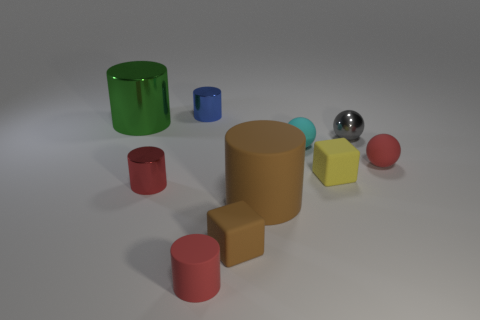What is the shape of the tiny shiny thing that is the same color as the small rubber cylinder?
Offer a very short reply. Cylinder. What is the size of the metal cylinder that is the same color as the small matte cylinder?
Give a very brief answer. Small. There is a tiny metallic thing that is both on the left side of the big brown rubber object and in front of the tiny blue shiny cylinder; what shape is it?
Keep it short and to the point. Cylinder. Is there a tiny metallic ball that has the same color as the tiny rubber cylinder?
Give a very brief answer. No. Are any large gray rubber balls visible?
Give a very brief answer. No. There is a tiny matte sphere that is behind the tiny red ball; what color is it?
Ensure brevity in your answer.  Cyan. Do the red shiny cylinder and the red rubber thing that is on the right side of the brown rubber block have the same size?
Provide a short and direct response. Yes. There is a metal object that is both left of the tiny brown block and in front of the large green metal cylinder; what size is it?
Make the answer very short. Small. Is there a cyan ball that has the same material as the gray thing?
Keep it short and to the point. No. What is the shape of the yellow rubber object?
Ensure brevity in your answer.  Cube. 